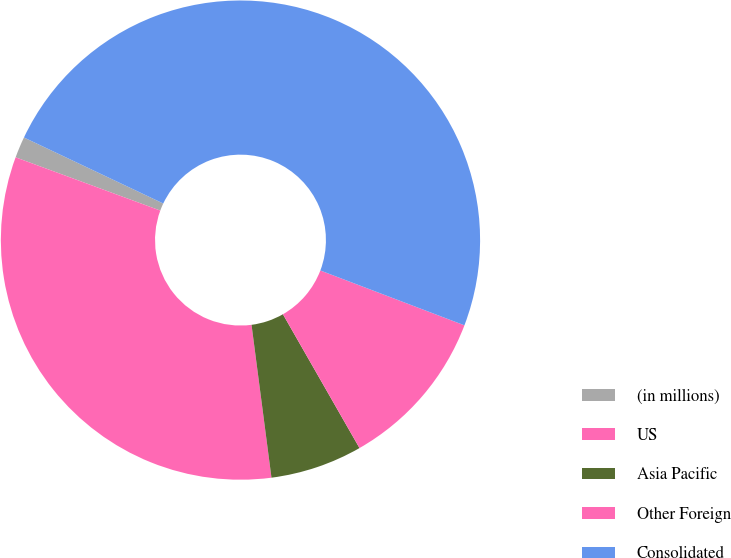Convert chart to OTSL. <chart><loc_0><loc_0><loc_500><loc_500><pie_chart><fcel>(in millions)<fcel>US<fcel>Asia Pacific<fcel>Other Foreign<fcel>Consolidated<nl><fcel>1.43%<fcel>32.68%<fcel>6.21%<fcel>10.94%<fcel>48.75%<nl></chart> 